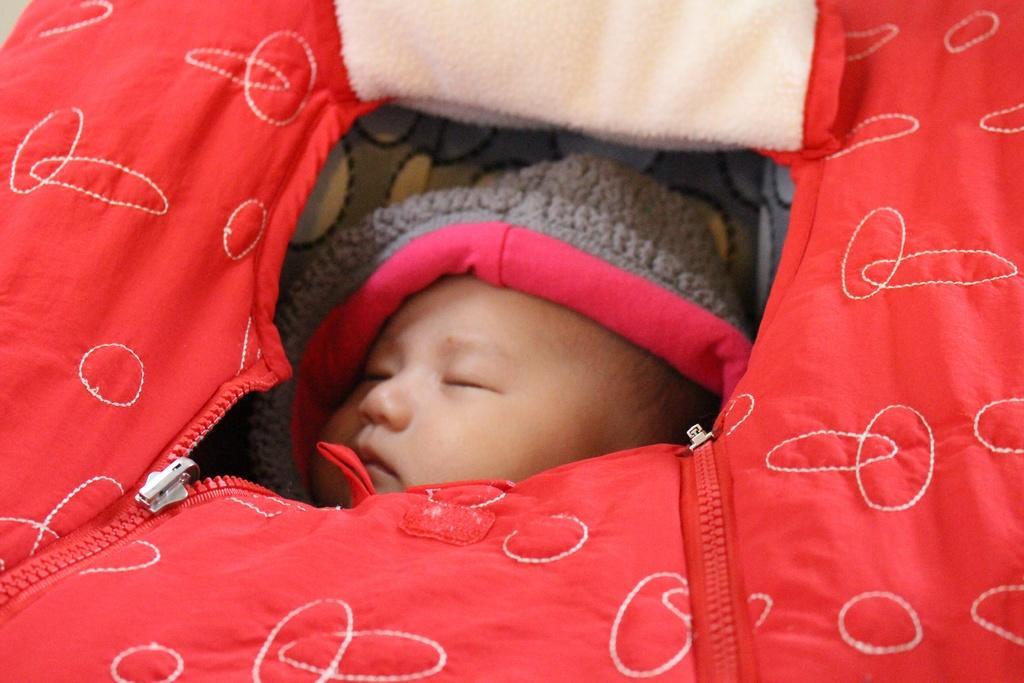Please provide a concise description of this image. In the foreground of this picture, there is a baby in red colored baby cart. 